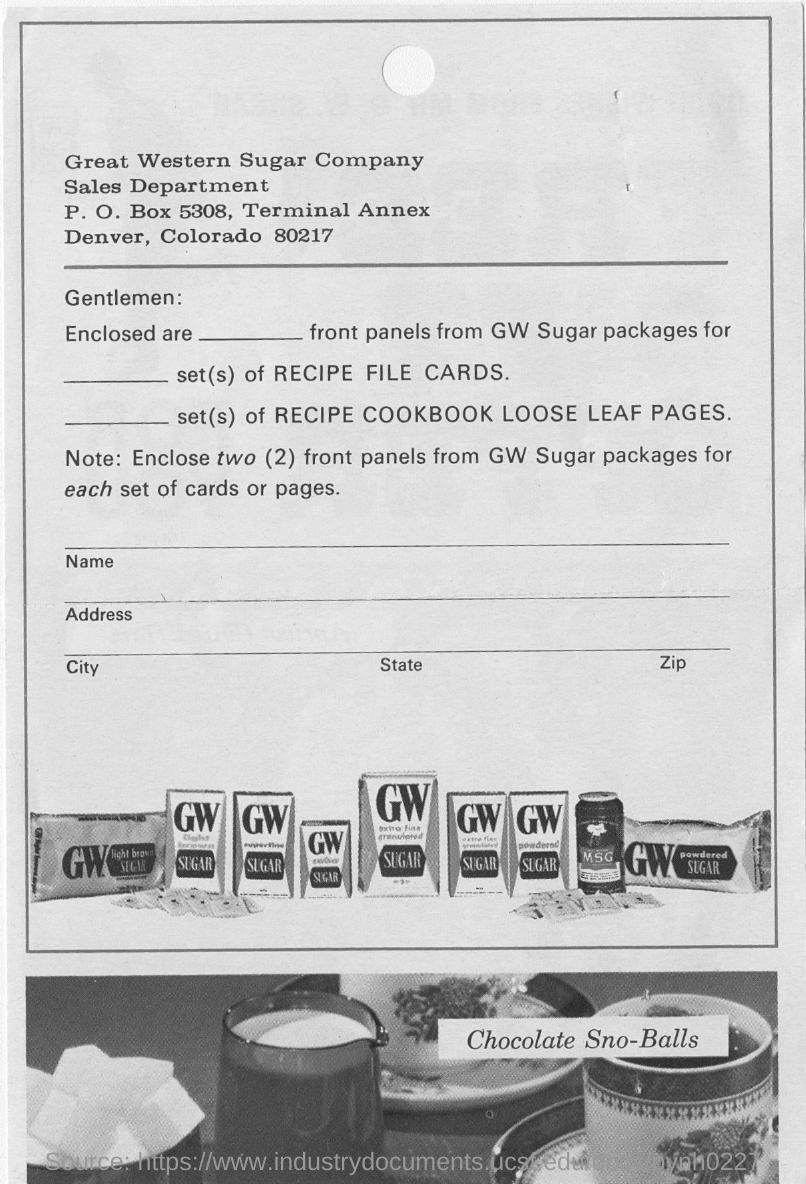Specify some key components in this picture. The two letters in bold on the packets in the first picture are GW. The bottom picture depicts the inscription "Chocolate Sno-Balls" written in a clear and legible font. 